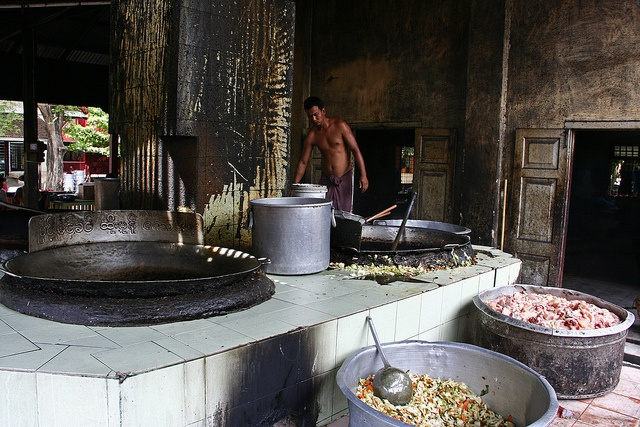Describe the objects in this image and their specific colors. I can see bowl in black, darkgray, gray, and lightgray tones, bowl in black, gray, lightgray, and darkgray tones, people in black, maroon, and brown tones, carrot in black, ivory, tan, and darkgray tones, and spoon in black, gray, darkgray, lightgray, and darkgreen tones in this image. 